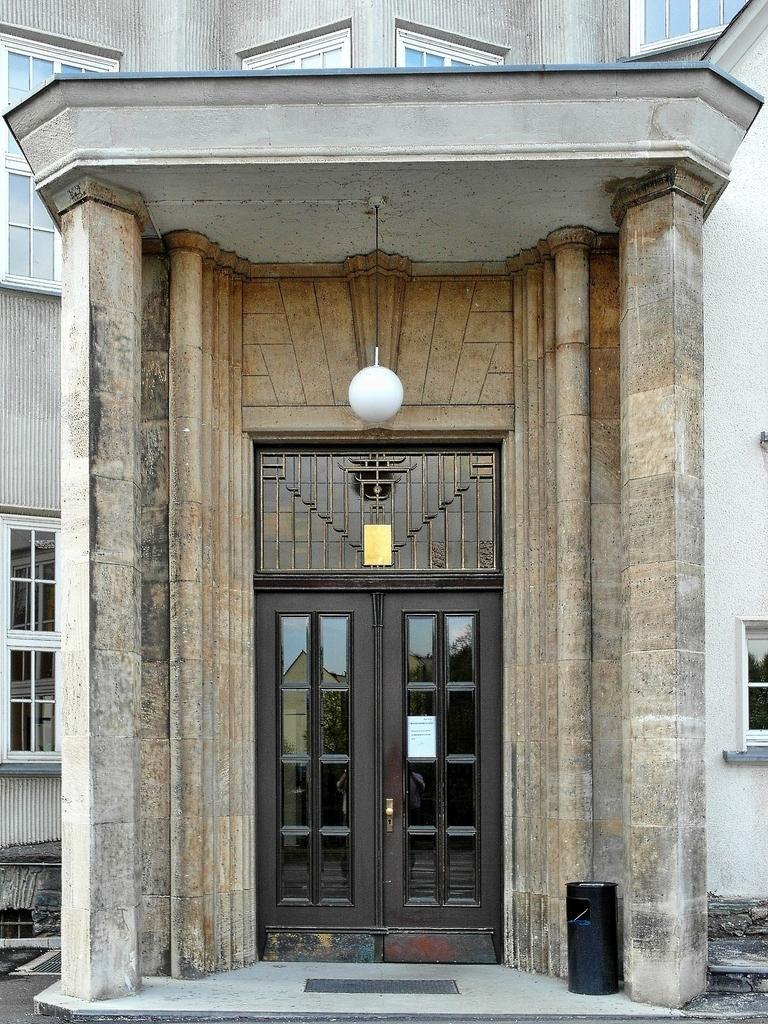In one or two sentences, can you explain what this image depicts? In this image we can see the entrance of a building with a door. We can also see the windows, light hangs from the ceiling. There is also a black color object on the surface. 